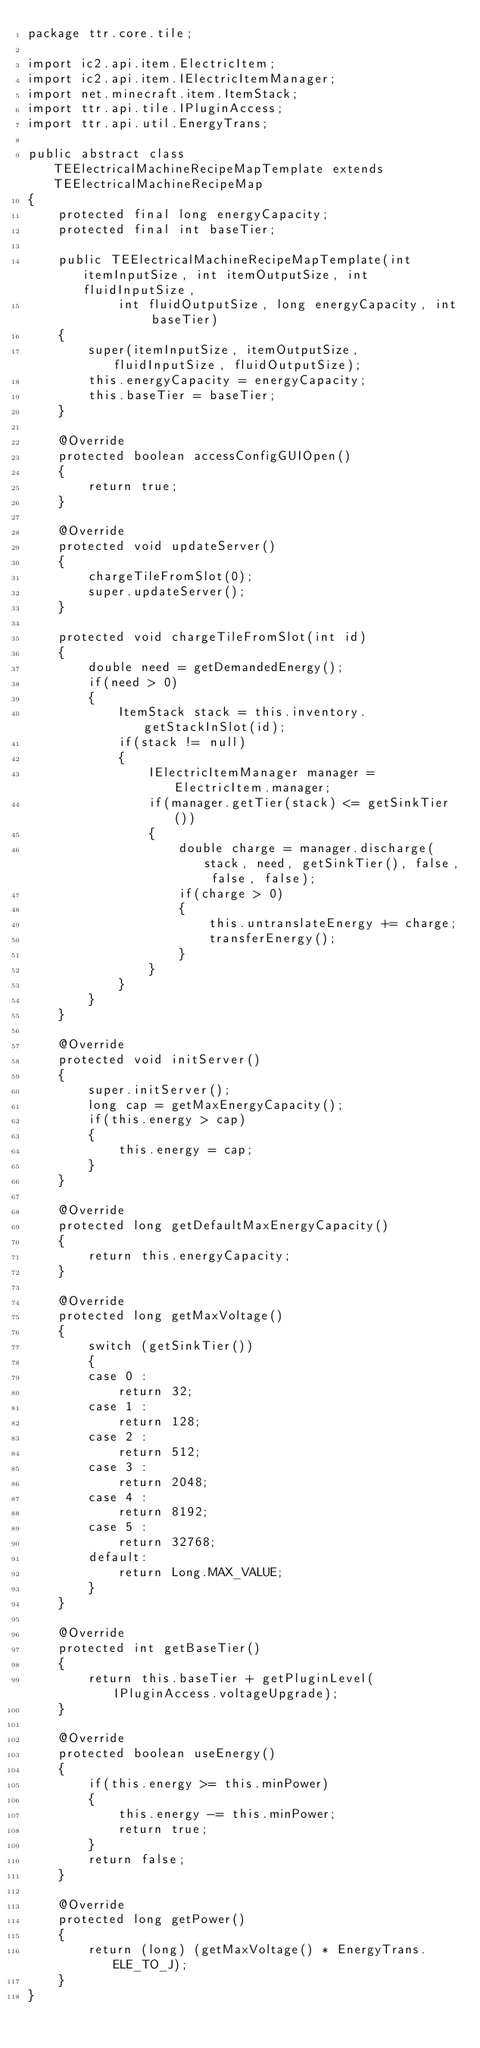<code> <loc_0><loc_0><loc_500><loc_500><_Java_>package ttr.core.tile;

import ic2.api.item.ElectricItem;
import ic2.api.item.IElectricItemManager;
import net.minecraft.item.ItemStack;
import ttr.api.tile.IPluginAccess;
import ttr.api.util.EnergyTrans;

public abstract class TEElectricalMachineRecipeMapTemplate extends TEElectricalMachineRecipeMap
{
	protected final long energyCapacity;
	protected final int baseTier;
	
	public TEElectricalMachineRecipeMapTemplate(int itemInputSize, int itemOutputSize, int fluidInputSize,
			int fluidOutputSize, long energyCapacity, int baseTier)
	{
		super(itemInputSize, itemOutputSize, fluidInputSize, fluidOutputSize);
		this.energyCapacity = energyCapacity;
		this.baseTier = baseTier;
	}
	
	@Override
	protected boolean accessConfigGUIOpen()
	{
		return true;
	}
	
	@Override
	protected void updateServer()
	{
		chargeTileFromSlot(0);
		super.updateServer();
	}
	
	protected void chargeTileFromSlot(int id)
	{
		double need = getDemandedEnergy();
		if(need > 0)
		{
			ItemStack stack = this.inventory.getStackInSlot(id);
			if(stack != null)
			{
				IElectricItemManager manager = ElectricItem.manager;
				if(manager.getTier(stack) <= getSinkTier())
				{
					double charge = manager.discharge(stack, need, getSinkTier(), false, false, false);
					if(charge > 0)
					{
						this.untranslateEnergy += charge;
						transferEnergy();
					}
				}
			}
		}
	}
	
	@Override
	protected void initServer()
	{
		super.initServer();
		long cap = getMaxEnergyCapacity();
		if(this.energy > cap)
		{
			this.energy = cap;
		}
	}
	
	@Override
	protected long getDefaultMaxEnergyCapacity()
	{
		return this.energyCapacity;
	}
	
	@Override
	protected long getMaxVoltage()
	{
		switch (getSinkTier())
		{
		case 0 :
			return 32;
		case 1 :
			return 128;
		case 2 :
			return 512;
		case 3 :
			return 2048;
		case 4 :
			return 8192;
		case 5 :
			return 32768;
		default:
			return Long.MAX_VALUE;
		}
	}
	
	@Override
	protected int getBaseTier()
	{
		return this.baseTier + getPluginLevel(IPluginAccess.voltageUpgrade);
	}
	
	@Override
	protected boolean useEnergy()
	{
		if(this.energy >= this.minPower)
		{
			this.energy -= this.minPower;
			return true;
		}
		return false;
	}
	
	@Override
	protected long getPower()
	{
		return (long) (getMaxVoltage() * EnergyTrans.ELE_TO_J);
	}
}</code> 